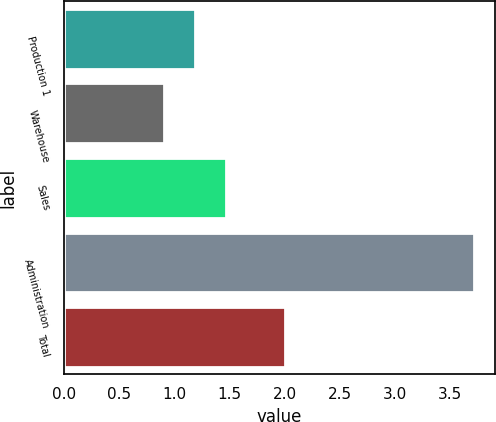Convert chart to OTSL. <chart><loc_0><loc_0><loc_500><loc_500><bar_chart><fcel>Production 1<fcel>Warehouse<fcel>Sales<fcel>Administration<fcel>Total<nl><fcel>1.19<fcel>0.91<fcel>1.47<fcel>3.72<fcel>2<nl></chart> 